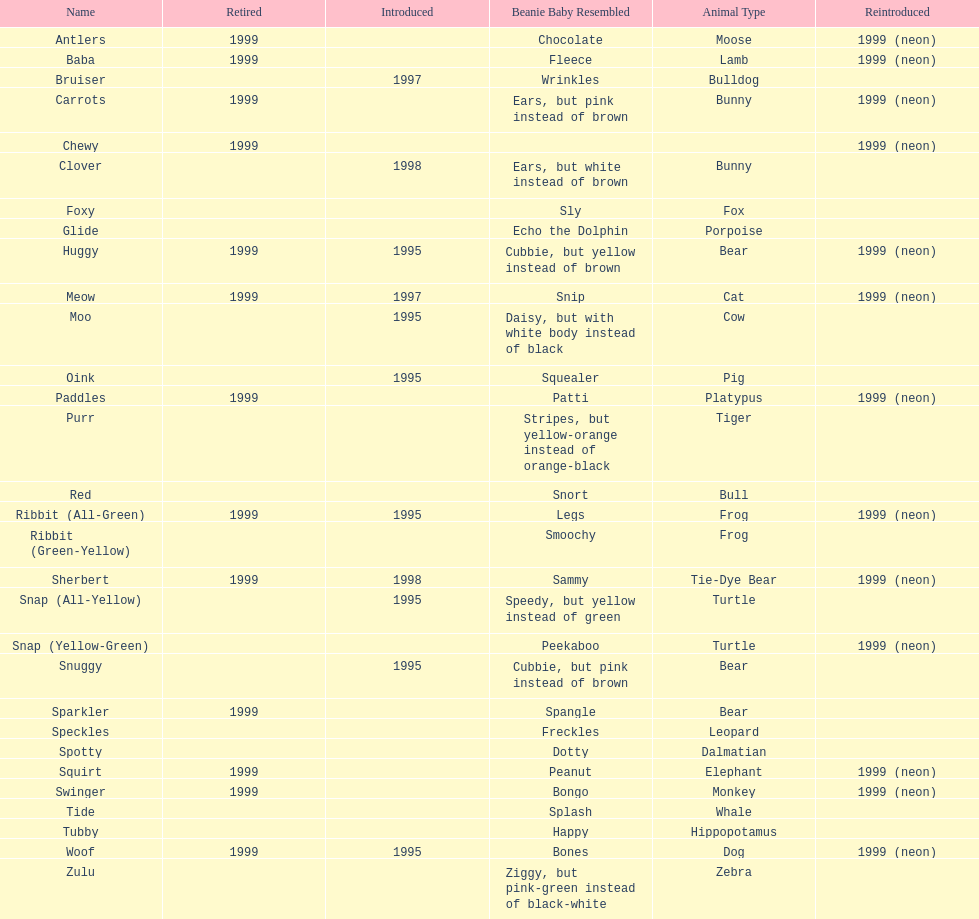What are the types of pillow pal animals? Antlers, Moose, Lamb, Bulldog, Bunny, , Bunny, Fox, Porpoise, Bear, Cat, Cow, Pig, Platypus, Tiger, Bull, Frog, Frog, Tie-Dye Bear, Turtle, Turtle, Bear, Bear, Leopard, Dalmatian, Elephant, Monkey, Whale, Hippopotamus, Dog, Zebra. Of those, which is a dalmatian? Dalmatian. What is the name of the dalmatian? Spotty. 